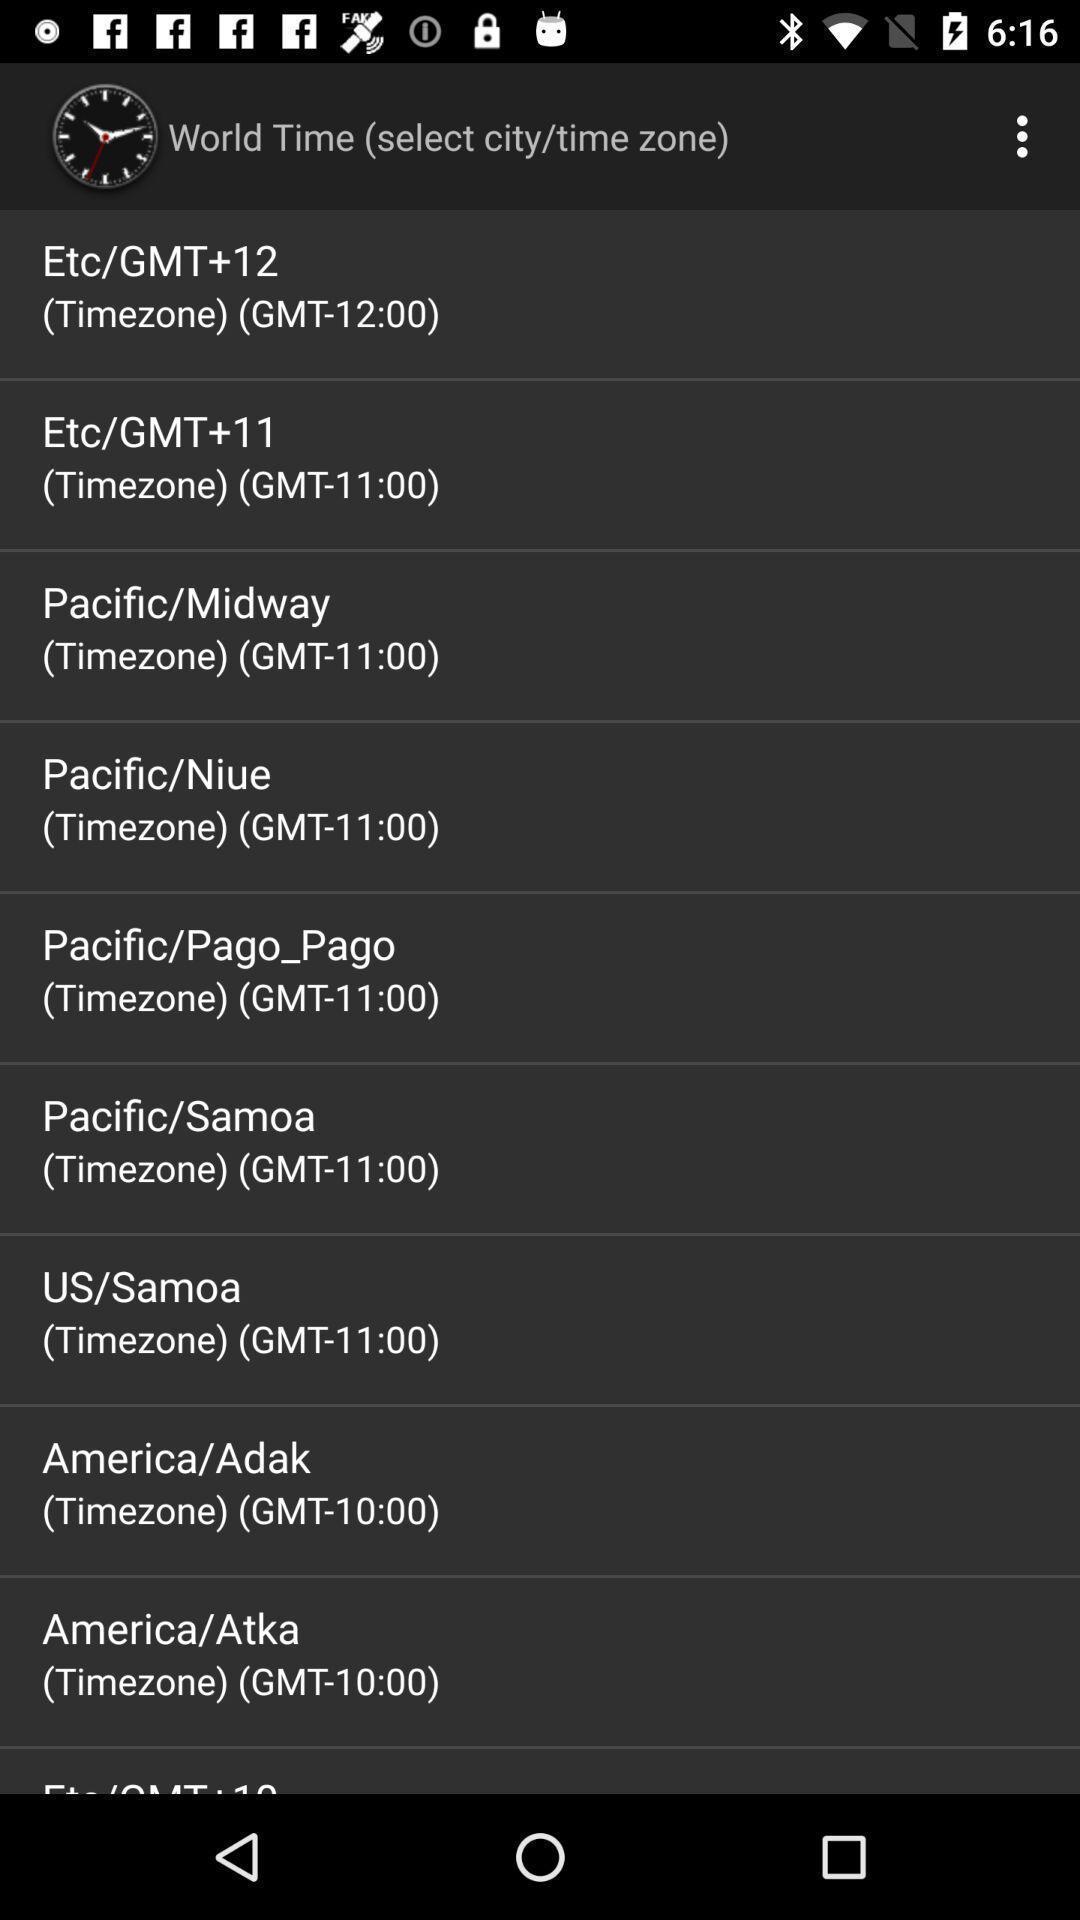What can you discern from this picture? Screen displaying various timezone. 